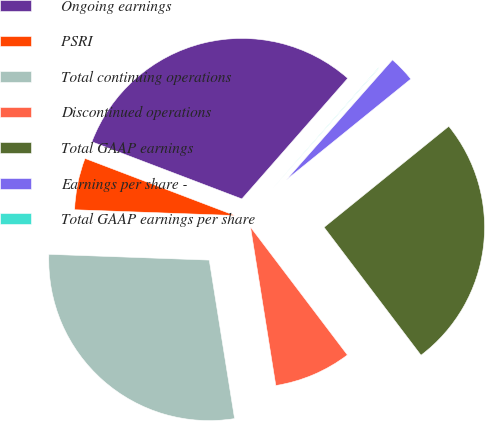<chart> <loc_0><loc_0><loc_500><loc_500><pie_chart><fcel>Ongoing earnings<fcel>PSRI<fcel>Total continuing operations<fcel>Discontinued operations<fcel>Total GAAP earnings<fcel>Earnings per share -<fcel>Total GAAP earnings per share<nl><fcel>30.68%<fcel>5.22%<fcel>28.1%<fcel>7.8%<fcel>25.52%<fcel>2.64%<fcel>0.06%<nl></chart> 